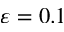<formula> <loc_0><loc_0><loc_500><loc_500>\varepsilon = 0 . 1</formula> 